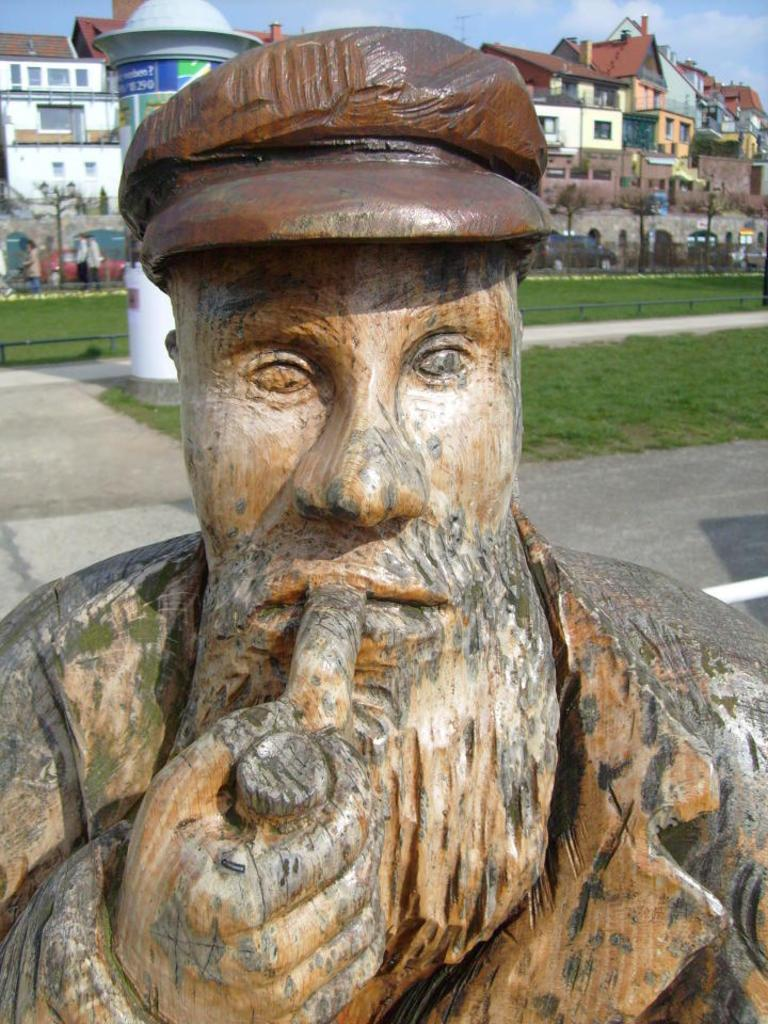What is the main subject of the picture? The main subject of the picture is a statue. What can be seen in the background of the picture? There is grass, buildings, and people in the background of the picture. What is visible at the top of the image? The sky is visible at the top of the image. What type of cloud is floating around the statue's neck in the image? There is no cloud present in the image, and the statue's neck is not mentioned in the provided facts. 